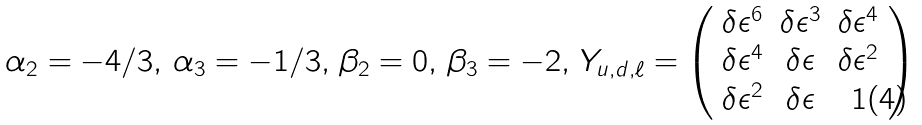Convert formula to latex. <formula><loc_0><loc_0><loc_500><loc_500>\alpha _ { 2 } = - 4 / 3 , \, \alpha _ { 3 } = - 1 / 3 , \, \beta _ { 2 } = 0 , \, \beta _ { 3 } = - 2 , \, Y _ { u , d , \ell } = \left ( \begin{array} { c c c } \delta { \epsilon } ^ { 6 } & \delta { \epsilon } ^ { 3 } & \delta { \epsilon } ^ { 4 } \\ \delta { \epsilon } ^ { 4 } & \delta { \epsilon } & \delta { \epsilon } ^ { 2 } \\ \delta { \epsilon } ^ { 2 } & \delta { \epsilon } & 1 \\ \end{array} \right )</formula> 